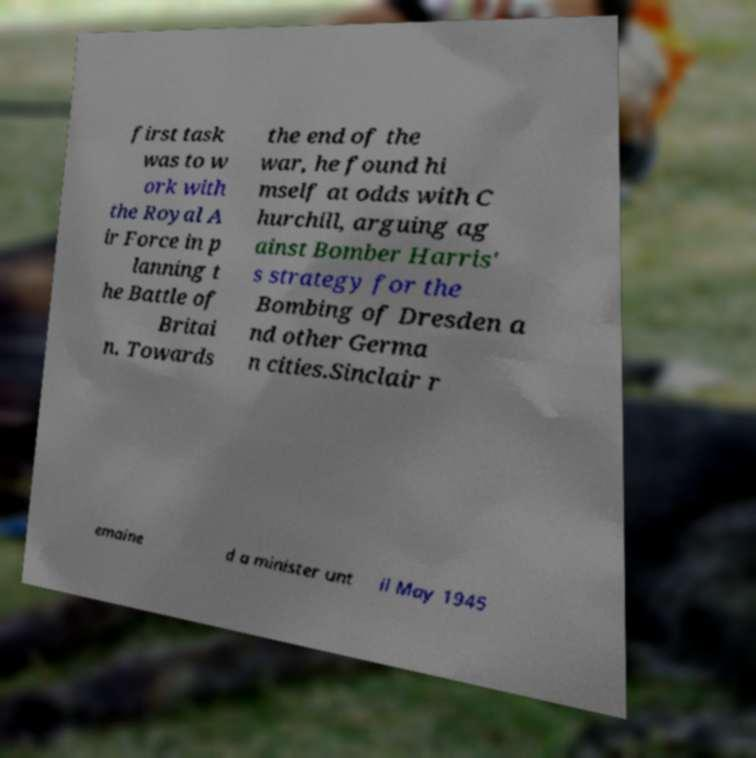There's text embedded in this image that I need extracted. Can you transcribe it verbatim? first task was to w ork with the Royal A ir Force in p lanning t he Battle of Britai n. Towards the end of the war, he found hi mself at odds with C hurchill, arguing ag ainst Bomber Harris' s strategy for the Bombing of Dresden a nd other Germa n cities.Sinclair r emaine d a minister unt il May 1945 